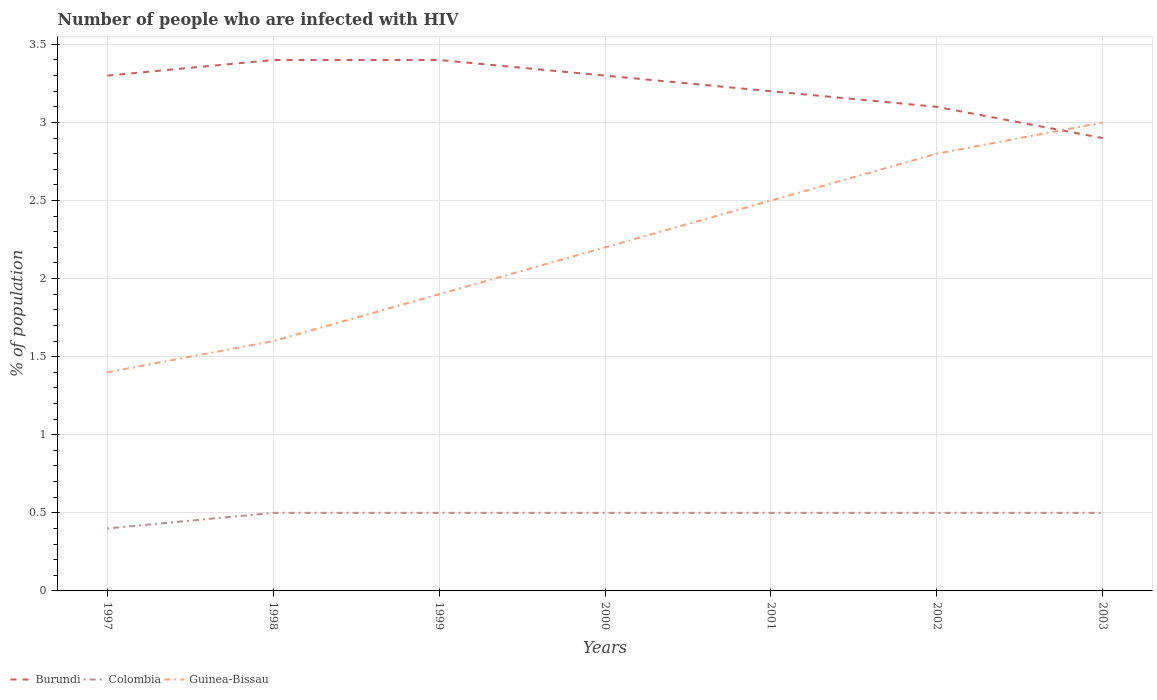How many different coloured lines are there?
Provide a succinct answer. 3. Is the number of lines equal to the number of legend labels?
Provide a short and direct response. Yes. Across all years, what is the maximum percentage of HIV infected population in in Burundi?
Your answer should be compact. 2.9. In which year was the percentage of HIV infected population in in Guinea-Bissau maximum?
Provide a short and direct response. 1997. What is the total percentage of HIV infected population in in Colombia in the graph?
Provide a short and direct response. 0. What is the difference between the highest and the second highest percentage of HIV infected population in in Colombia?
Your response must be concise. 0.1. What is the difference between the highest and the lowest percentage of HIV infected population in in Burundi?
Offer a terse response. 4. How many lines are there?
Your answer should be compact. 3. What is the difference between two consecutive major ticks on the Y-axis?
Offer a very short reply. 0.5. Are the values on the major ticks of Y-axis written in scientific E-notation?
Provide a succinct answer. No. Does the graph contain any zero values?
Give a very brief answer. No. Does the graph contain grids?
Your answer should be very brief. Yes. Where does the legend appear in the graph?
Make the answer very short. Bottom left. How are the legend labels stacked?
Offer a terse response. Horizontal. What is the title of the graph?
Provide a succinct answer. Number of people who are infected with HIV. Does "Andorra" appear as one of the legend labels in the graph?
Offer a very short reply. No. What is the label or title of the Y-axis?
Keep it short and to the point. % of population. What is the % of population of Guinea-Bissau in 1997?
Give a very brief answer. 1.4. What is the % of population of Burundi in 1999?
Give a very brief answer. 3.4. What is the % of population of Colombia in 1999?
Your answer should be very brief. 0.5. What is the % of population in Guinea-Bissau in 1999?
Ensure brevity in your answer.  1.9. What is the % of population of Colombia in 2000?
Your response must be concise. 0.5. What is the % of population in Burundi in 2002?
Your answer should be very brief. 3.1. What is the % of population in Colombia in 2002?
Make the answer very short. 0.5. What is the % of population of Guinea-Bissau in 2002?
Give a very brief answer. 2.8. What is the % of population of Burundi in 2003?
Offer a very short reply. 2.9. Across all years, what is the maximum % of population in Burundi?
Ensure brevity in your answer.  3.4. Across all years, what is the maximum % of population of Colombia?
Your response must be concise. 0.5. Across all years, what is the minimum % of population in Colombia?
Make the answer very short. 0.4. Across all years, what is the minimum % of population in Guinea-Bissau?
Offer a terse response. 1.4. What is the total % of population of Burundi in the graph?
Keep it short and to the point. 22.6. What is the total % of population in Colombia in the graph?
Provide a succinct answer. 3.4. What is the total % of population of Guinea-Bissau in the graph?
Your answer should be very brief. 15.4. What is the difference between the % of population of Guinea-Bissau in 1997 and that in 1998?
Offer a very short reply. -0.2. What is the difference between the % of population of Burundi in 1997 and that in 1999?
Give a very brief answer. -0.1. What is the difference between the % of population in Guinea-Bissau in 1997 and that in 1999?
Keep it short and to the point. -0.5. What is the difference between the % of population in Burundi in 1997 and that in 2000?
Your answer should be compact. 0. What is the difference between the % of population of Guinea-Bissau in 1997 and that in 2000?
Ensure brevity in your answer.  -0.8. What is the difference between the % of population of Guinea-Bissau in 1997 and that in 2001?
Offer a terse response. -1.1. What is the difference between the % of population of Burundi in 1997 and that in 2002?
Give a very brief answer. 0.2. What is the difference between the % of population of Colombia in 1997 and that in 2002?
Provide a short and direct response. -0.1. What is the difference between the % of population in Guinea-Bissau in 1997 and that in 2002?
Keep it short and to the point. -1.4. What is the difference between the % of population in Burundi in 1997 and that in 2003?
Offer a terse response. 0.4. What is the difference between the % of population in Burundi in 1998 and that in 1999?
Give a very brief answer. 0. What is the difference between the % of population of Colombia in 1998 and that in 1999?
Keep it short and to the point. 0. What is the difference between the % of population of Guinea-Bissau in 1998 and that in 1999?
Your answer should be compact. -0.3. What is the difference between the % of population in Colombia in 1998 and that in 2000?
Ensure brevity in your answer.  0. What is the difference between the % of population in Burundi in 1998 and that in 2001?
Your answer should be very brief. 0.2. What is the difference between the % of population of Guinea-Bissau in 1998 and that in 2001?
Keep it short and to the point. -0.9. What is the difference between the % of population of Burundi in 1998 and that in 2002?
Make the answer very short. 0.3. What is the difference between the % of population in Colombia in 1998 and that in 2002?
Make the answer very short. 0. What is the difference between the % of population of Burundi in 1998 and that in 2003?
Provide a short and direct response. 0.5. What is the difference between the % of population in Guinea-Bissau in 1998 and that in 2003?
Give a very brief answer. -1.4. What is the difference between the % of population in Burundi in 1999 and that in 2000?
Make the answer very short. 0.1. What is the difference between the % of population of Colombia in 1999 and that in 2000?
Your response must be concise. 0. What is the difference between the % of population of Burundi in 1999 and that in 2001?
Offer a very short reply. 0.2. What is the difference between the % of population in Guinea-Bissau in 1999 and that in 2001?
Give a very brief answer. -0.6. What is the difference between the % of population in Colombia in 1999 and that in 2002?
Keep it short and to the point. 0. What is the difference between the % of population in Guinea-Bissau in 1999 and that in 2002?
Ensure brevity in your answer.  -0.9. What is the difference between the % of population in Guinea-Bissau in 1999 and that in 2003?
Your answer should be very brief. -1.1. What is the difference between the % of population in Guinea-Bissau in 2000 and that in 2001?
Your answer should be compact. -0.3. What is the difference between the % of population of Burundi in 2000 and that in 2002?
Your answer should be compact. 0.2. What is the difference between the % of population in Colombia in 2000 and that in 2002?
Keep it short and to the point. 0. What is the difference between the % of population in Burundi in 2000 and that in 2003?
Offer a very short reply. 0.4. What is the difference between the % of population in Guinea-Bissau in 2000 and that in 2003?
Ensure brevity in your answer.  -0.8. What is the difference between the % of population of Burundi in 2001 and that in 2002?
Provide a succinct answer. 0.1. What is the difference between the % of population in Colombia in 2001 and that in 2002?
Give a very brief answer. 0. What is the difference between the % of population in Burundi in 2001 and that in 2003?
Your response must be concise. 0.3. What is the difference between the % of population of Colombia in 2001 and that in 2003?
Offer a very short reply. 0. What is the difference between the % of population of Burundi in 1997 and the % of population of Colombia in 1998?
Make the answer very short. 2.8. What is the difference between the % of population of Burundi in 1997 and the % of population of Colombia in 1999?
Ensure brevity in your answer.  2.8. What is the difference between the % of population in Burundi in 1997 and the % of population in Colombia in 2000?
Provide a short and direct response. 2.8. What is the difference between the % of population in Burundi in 1997 and the % of population in Guinea-Bissau in 2001?
Provide a succinct answer. 0.8. What is the difference between the % of population in Burundi in 1997 and the % of population in Colombia in 2002?
Your answer should be very brief. 2.8. What is the difference between the % of population in Burundi in 1997 and the % of population in Guinea-Bissau in 2002?
Keep it short and to the point. 0.5. What is the difference between the % of population in Burundi in 1997 and the % of population in Colombia in 2003?
Provide a short and direct response. 2.8. What is the difference between the % of population of Burundi in 1997 and the % of population of Guinea-Bissau in 2003?
Your answer should be very brief. 0.3. What is the difference between the % of population in Colombia in 1997 and the % of population in Guinea-Bissau in 2003?
Provide a succinct answer. -2.6. What is the difference between the % of population in Burundi in 1998 and the % of population in Colombia in 1999?
Offer a terse response. 2.9. What is the difference between the % of population of Burundi in 1998 and the % of population of Guinea-Bissau in 1999?
Give a very brief answer. 1.5. What is the difference between the % of population of Burundi in 1998 and the % of population of Guinea-Bissau in 2000?
Make the answer very short. 1.2. What is the difference between the % of population in Burundi in 1998 and the % of population in Guinea-Bissau in 2001?
Offer a very short reply. 0.9. What is the difference between the % of population in Colombia in 1998 and the % of population in Guinea-Bissau in 2002?
Keep it short and to the point. -2.3. What is the difference between the % of population in Burundi in 1998 and the % of population in Colombia in 2003?
Your response must be concise. 2.9. What is the difference between the % of population of Burundi in 1998 and the % of population of Guinea-Bissau in 2003?
Ensure brevity in your answer.  0.4. What is the difference between the % of population of Burundi in 1999 and the % of population of Guinea-Bissau in 2000?
Make the answer very short. 1.2. What is the difference between the % of population of Colombia in 1999 and the % of population of Guinea-Bissau in 2000?
Your answer should be very brief. -1.7. What is the difference between the % of population in Colombia in 1999 and the % of population in Guinea-Bissau in 2001?
Make the answer very short. -2. What is the difference between the % of population in Colombia in 1999 and the % of population in Guinea-Bissau in 2002?
Make the answer very short. -2.3. What is the difference between the % of population of Burundi in 1999 and the % of population of Guinea-Bissau in 2003?
Offer a very short reply. 0.4. What is the difference between the % of population in Colombia in 1999 and the % of population in Guinea-Bissau in 2003?
Your answer should be compact. -2.5. What is the difference between the % of population of Burundi in 2000 and the % of population of Colombia in 2001?
Make the answer very short. 2.8. What is the difference between the % of population in Burundi in 2000 and the % of population in Guinea-Bissau in 2001?
Your response must be concise. 0.8. What is the difference between the % of population in Colombia in 2000 and the % of population in Guinea-Bissau in 2001?
Give a very brief answer. -2. What is the difference between the % of population in Burundi in 2000 and the % of population in Guinea-Bissau in 2003?
Offer a terse response. 0.3. What is the difference between the % of population of Colombia in 2000 and the % of population of Guinea-Bissau in 2003?
Keep it short and to the point. -2.5. What is the difference between the % of population in Burundi in 2001 and the % of population in Colombia in 2002?
Your answer should be very brief. 2.7. What is the difference between the % of population in Burundi in 2001 and the % of population in Guinea-Bissau in 2002?
Your answer should be compact. 0.4. What is the average % of population in Burundi per year?
Provide a short and direct response. 3.23. What is the average % of population in Colombia per year?
Your answer should be very brief. 0.49. In the year 1997, what is the difference between the % of population of Burundi and % of population of Guinea-Bissau?
Your response must be concise. 1.9. In the year 1998, what is the difference between the % of population of Burundi and % of population of Colombia?
Offer a terse response. 2.9. In the year 1998, what is the difference between the % of population in Burundi and % of population in Guinea-Bissau?
Ensure brevity in your answer.  1.8. In the year 1999, what is the difference between the % of population in Burundi and % of population in Guinea-Bissau?
Make the answer very short. 1.5. In the year 2000, what is the difference between the % of population of Burundi and % of population of Colombia?
Provide a succinct answer. 2.8. In the year 2000, what is the difference between the % of population in Colombia and % of population in Guinea-Bissau?
Your answer should be compact. -1.7. In the year 2002, what is the difference between the % of population in Burundi and % of population in Colombia?
Offer a very short reply. 2.6. In the year 2003, what is the difference between the % of population in Burundi and % of population in Guinea-Bissau?
Give a very brief answer. -0.1. What is the ratio of the % of population in Burundi in 1997 to that in 1998?
Make the answer very short. 0.97. What is the ratio of the % of population of Guinea-Bissau in 1997 to that in 1998?
Your response must be concise. 0.88. What is the ratio of the % of population in Burundi in 1997 to that in 1999?
Your answer should be very brief. 0.97. What is the ratio of the % of population of Guinea-Bissau in 1997 to that in 1999?
Keep it short and to the point. 0.74. What is the ratio of the % of population of Guinea-Bissau in 1997 to that in 2000?
Offer a very short reply. 0.64. What is the ratio of the % of population of Burundi in 1997 to that in 2001?
Offer a very short reply. 1.03. What is the ratio of the % of population of Guinea-Bissau in 1997 to that in 2001?
Give a very brief answer. 0.56. What is the ratio of the % of population of Burundi in 1997 to that in 2002?
Offer a very short reply. 1.06. What is the ratio of the % of population of Colombia in 1997 to that in 2002?
Give a very brief answer. 0.8. What is the ratio of the % of population in Guinea-Bissau in 1997 to that in 2002?
Ensure brevity in your answer.  0.5. What is the ratio of the % of population of Burundi in 1997 to that in 2003?
Your answer should be compact. 1.14. What is the ratio of the % of population of Colombia in 1997 to that in 2003?
Give a very brief answer. 0.8. What is the ratio of the % of population in Guinea-Bissau in 1997 to that in 2003?
Ensure brevity in your answer.  0.47. What is the ratio of the % of population in Burundi in 1998 to that in 1999?
Ensure brevity in your answer.  1. What is the ratio of the % of population in Colombia in 1998 to that in 1999?
Offer a terse response. 1. What is the ratio of the % of population in Guinea-Bissau in 1998 to that in 1999?
Ensure brevity in your answer.  0.84. What is the ratio of the % of population in Burundi in 1998 to that in 2000?
Make the answer very short. 1.03. What is the ratio of the % of population in Colombia in 1998 to that in 2000?
Ensure brevity in your answer.  1. What is the ratio of the % of population in Guinea-Bissau in 1998 to that in 2000?
Offer a terse response. 0.73. What is the ratio of the % of population of Burundi in 1998 to that in 2001?
Your response must be concise. 1.06. What is the ratio of the % of population of Colombia in 1998 to that in 2001?
Make the answer very short. 1. What is the ratio of the % of population of Guinea-Bissau in 1998 to that in 2001?
Your answer should be very brief. 0.64. What is the ratio of the % of population in Burundi in 1998 to that in 2002?
Give a very brief answer. 1.1. What is the ratio of the % of population in Colombia in 1998 to that in 2002?
Provide a succinct answer. 1. What is the ratio of the % of population of Guinea-Bissau in 1998 to that in 2002?
Provide a short and direct response. 0.57. What is the ratio of the % of population in Burundi in 1998 to that in 2003?
Provide a succinct answer. 1.17. What is the ratio of the % of population of Guinea-Bissau in 1998 to that in 2003?
Provide a succinct answer. 0.53. What is the ratio of the % of population in Burundi in 1999 to that in 2000?
Make the answer very short. 1.03. What is the ratio of the % of population of Colombia in 1999 to that in 2000?
Offer a very short reply. 1. What is the ratio of the % of population in Guinea-Bissau in 1999 to that in 2000?
Provide a succinct answer. 0.86. What is the ratio of the % of population in Guinea-Bissau in 1999 to that in 2001?
Ensure brevity in your answer.  0.76. What is the ratio of the % of population of Burundi in 1999 to that in 2002?
Your answer should be very brief. 1.1. What is the ratio of the % of population in Guinea-Bissau in 1999 to that in 2002?
Keep it short and to the point. 0.68. What is the ratio of the % of population in Burundi in 1999 to that in 2003?
Provide a short and direct response. 1.17. What is the ratio of the % of population in Guinea-Bissau in 1999 to that in 2003?
Your answer should be compact. 0.63. What is the ratio of the % of population of Burundi in 2000 to that in 2001?
Provide a succinct answer. 1.03. What is the ratio of the % of population in Colombia in 2000 to that in 2001?
Your answer should be very brief. 1. What is the ratio of the % of population in Guinea-Bissau in 2000 to that in 2001?
Your response must be concise. 0.88. What is the ratio of the % of population of Burundi in 2000 to that in 2002?
Keep it short and to the point. 1.06. What is the ratio of the % of population of Guinea-Bissau in 2000 to that in 2002?
Keep it short and to the point. 0.79. What is the ratio of the % of population of Burundi in 2000 to that in 2003?
Your response must be concise. 1.14. What is the ratio of the % of population of Guinea-Bissau in 2000 to that in 2003?
Provide a short and direct response. 0.73. What is the ratio of the % of population in Burundi in 2001 to that in 2002?
Offer a very short reply. 1.03. What is the ratio of the % of population of Colombia in 2001 to that in 2002?
Give a very brief answer. 1. What is the ratio of the % of population of Guinea-Bissau in 2001 to that in 2002?
Your answer should be compact. 0.89. What is the ratio of the % of population of Burundi in 2001 to that in 2003?
Offer a very short reply. 1.1. What is the ratio of the % of population in Burundi in 2002 to that in 2003?
Provide a short and direct response. 1.07. What is the difference between the highest and the lowest % of population of Burundi?
Give a very brief answer. 0.5. 